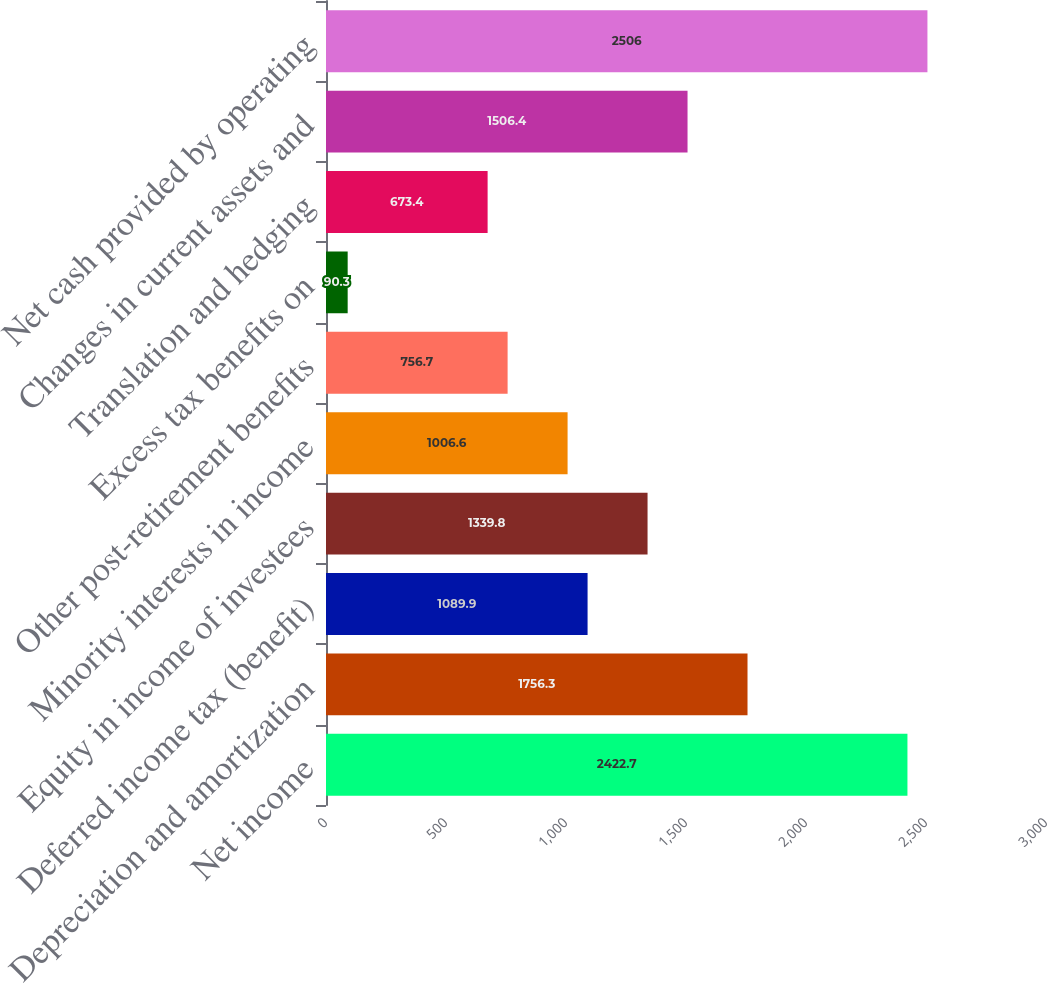Convert chart to OTSL. <chart><loc_0><loc_0><loc_500><loc_500><bar_chart><fcel>Net income<fcel>Depreciation and amortization<fcel>Deferred income tax (benefit)<fcel>Equity in income of investees<fcel>Minority interests in income<fcel>Other post-retirement benefits<fcel>Excess tax benefits on<fcel>Translation and hedging<fcel>Changes in current assets and<fcel>Net cash provided by operating<nl><fcel>2422.7<fcel>1756.3<fcel>1089.9<fcel>1339.8<fcel>1006.6<fcel>756.7<fcel>90.3<fcel>673.4<fcel>1506.4<fcel>2506<nl></chart> 